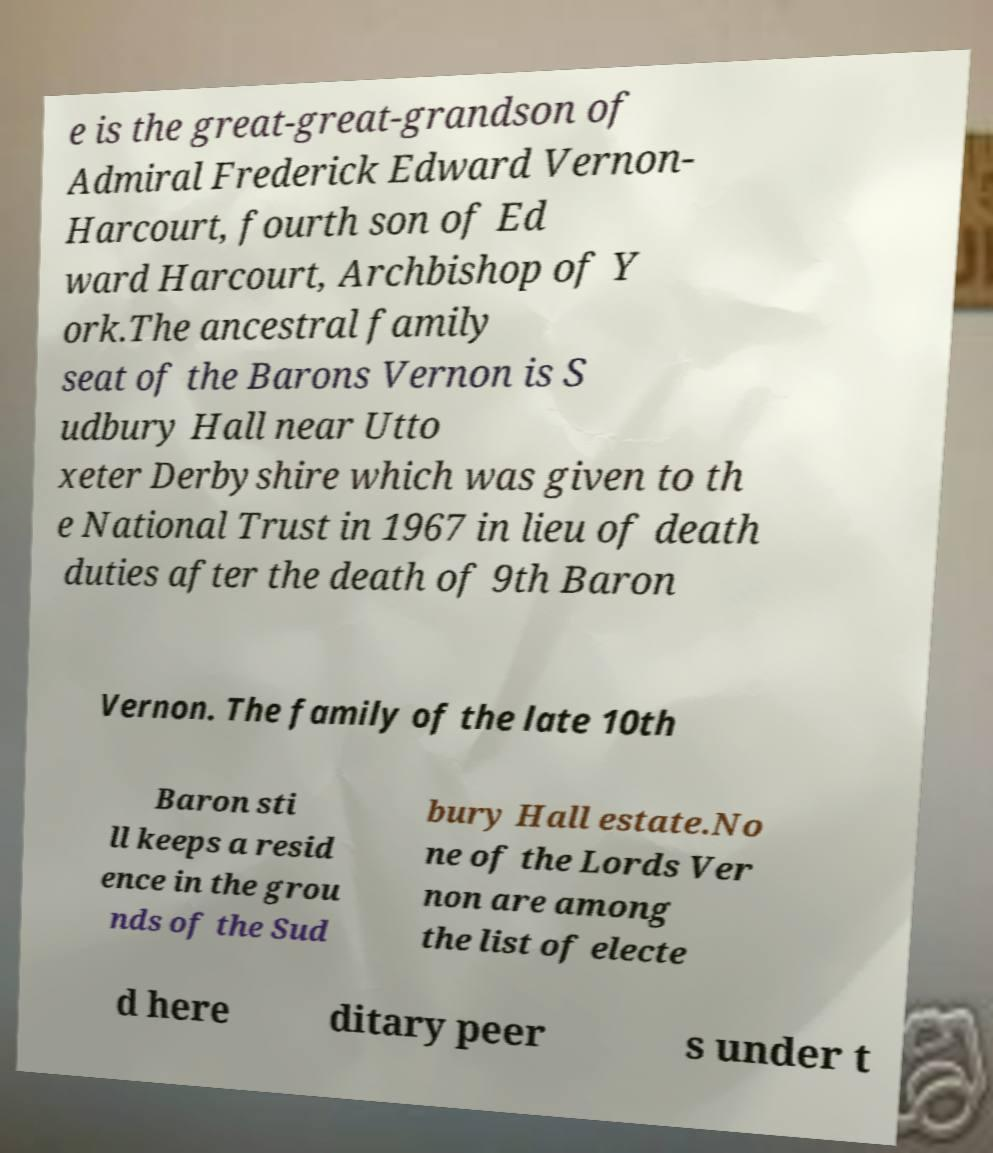Please identify and transcribe the text found in this image. e is the great-great-grandson of Admiral Frederick Edward Vernon- Harcourt, fourth son of Ed ward Harcourt, Archbishop of Y ork.The ancestral family seat of the Barons Vernon is S udbury Hall near Utto xeter Derbyshire which was given to th e National Trust in 1967 in lieu of death duties after the death of 9th Baron Vernon. The family of the late 10th Baron sti ll keeps a resid ence in the grou nds of the Sud bury Hall estate.No ne of the Lords Ver non are among the list of electe d here ditary peer s under t 